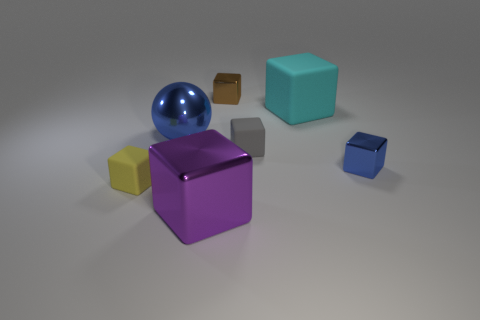Are there more big blocks than cubes?
Your response must be concise. No. What number of other things are the same material as the large cyan object?
Your response must be concise. 2. There is a small metallic thing that is in front of the blue metallic thing that is to the left of the cyan block; what number of large cyan matte things are behind it?
Provide a succinct answer. 1. What number of metal objects are either large balls or tiny red cylinders?
Provide a succinct answer. 1. There is a shiny cube that is left of the tiny metal block behind the cyan thing; what size is it?
Offer a terse response. Large. There is a big block that is on the left side of the tiny brown thing; does it have the same color as the metallic object that is behind the sphere?
Provide a short and direct response. No. There is a shiny object that is behind the large shiny block and on the left side of the tiny brown metal block; what is its color?
Provide a succinct answer. Blue. Is the tiny yellow object made of the same material as the blue sphere?
Offer a terse response. No. How many tiny things are either purple blocks or green matte spheres?
Offer a terse response. 0. Is there any other thing that has the same shape as the gray matte object?
Keep it short and to the point. Yes. 